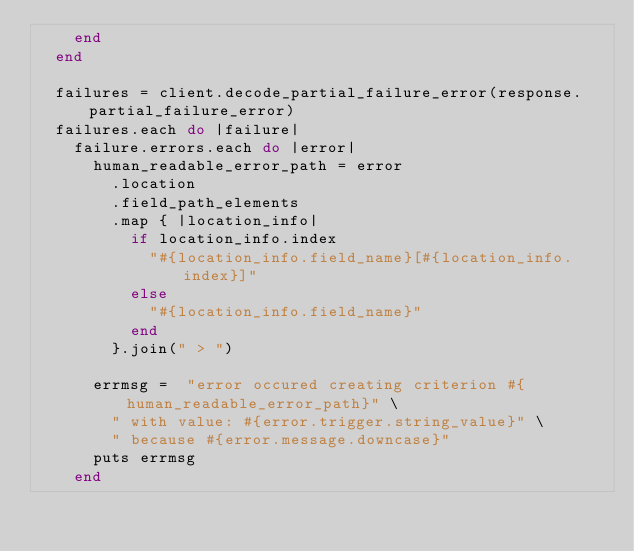<code> <loc_0><loc_0><loc_500><loc_500><_Ruby_>    end
  end

  failures = client.decode_partial_failure_error(response.partial_failure_error)
  failures.each do |failure|
    failure.errors.each do |error|
      human_readable_error_path = error
        .location
        .field_path_elements
        .map { |location_info|
          if location_info.index
            "#{location_info.field_name}[#{location_info.index}]"
          else
            "#{location_info.field_name}"
          end
        }.join(" > ")

      errmsg =  "error occured creating criterion #{human_readable_error_path}" \
        " with value: #{error.trigger.string_value}" \
        " because #{error.message.downcase}"
      puts errmsg
    end</code> 